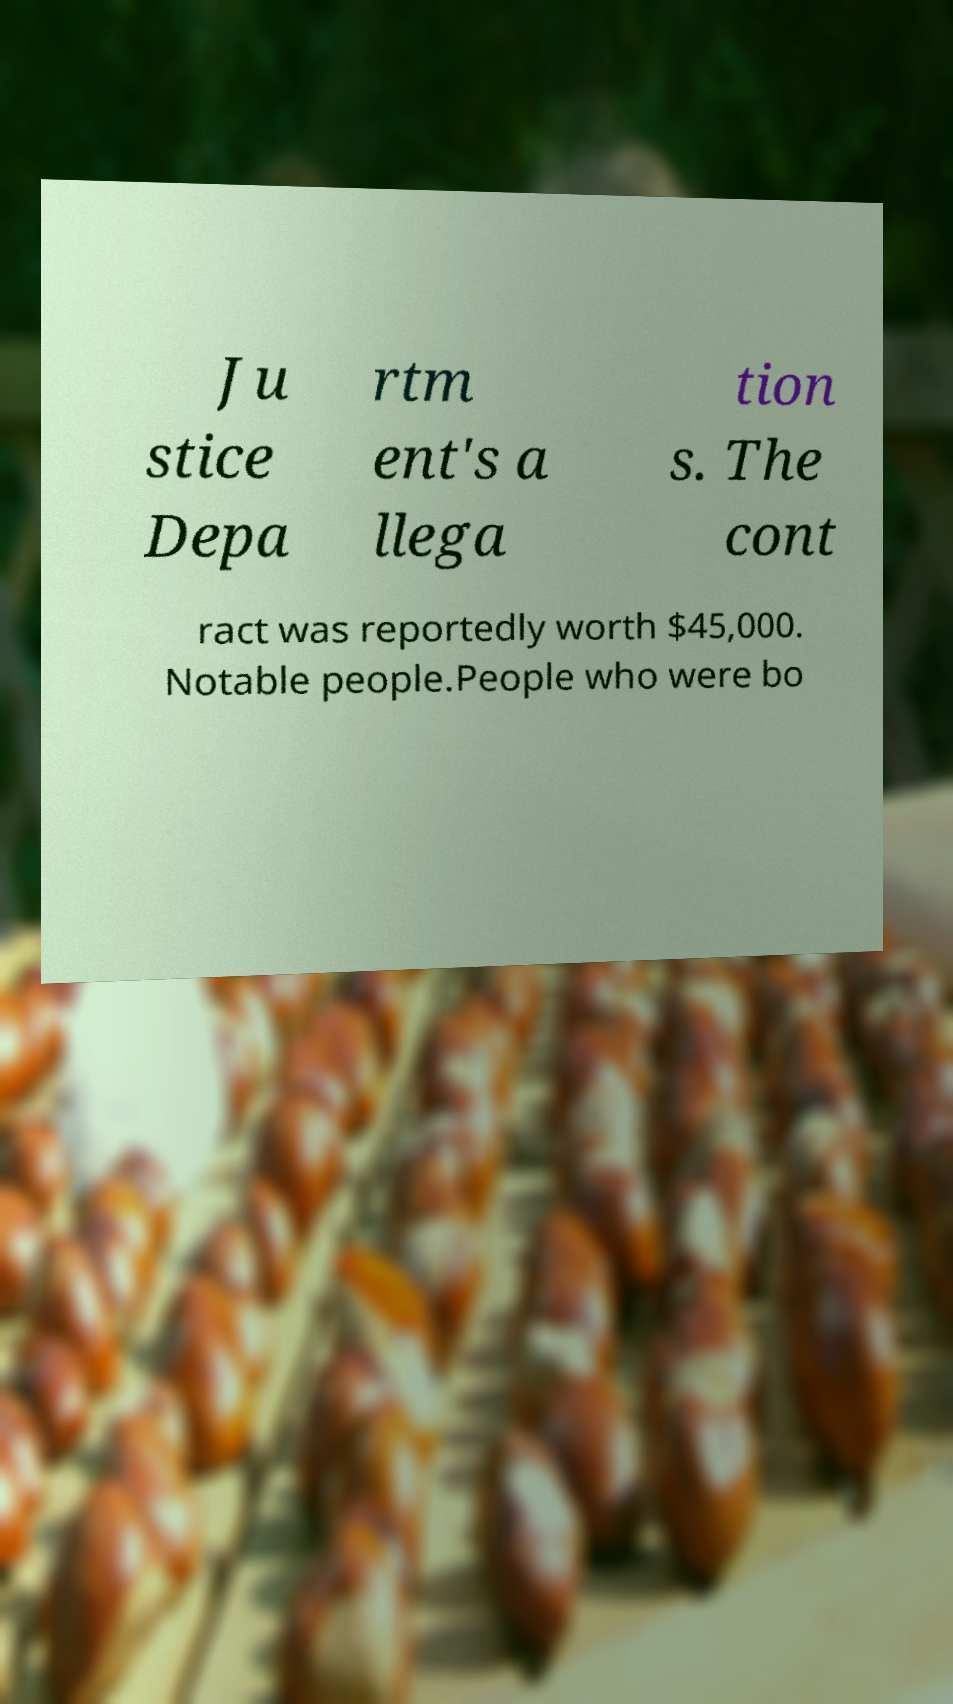Can you read and provide the text displayed in the image?This photo seems to have some interesting text. Can you extract and type it out for me? Ju stice Depa rtm ent's a llega tion s. The cont ract was reportedly worth $45,000. Notable people.People who were bo 